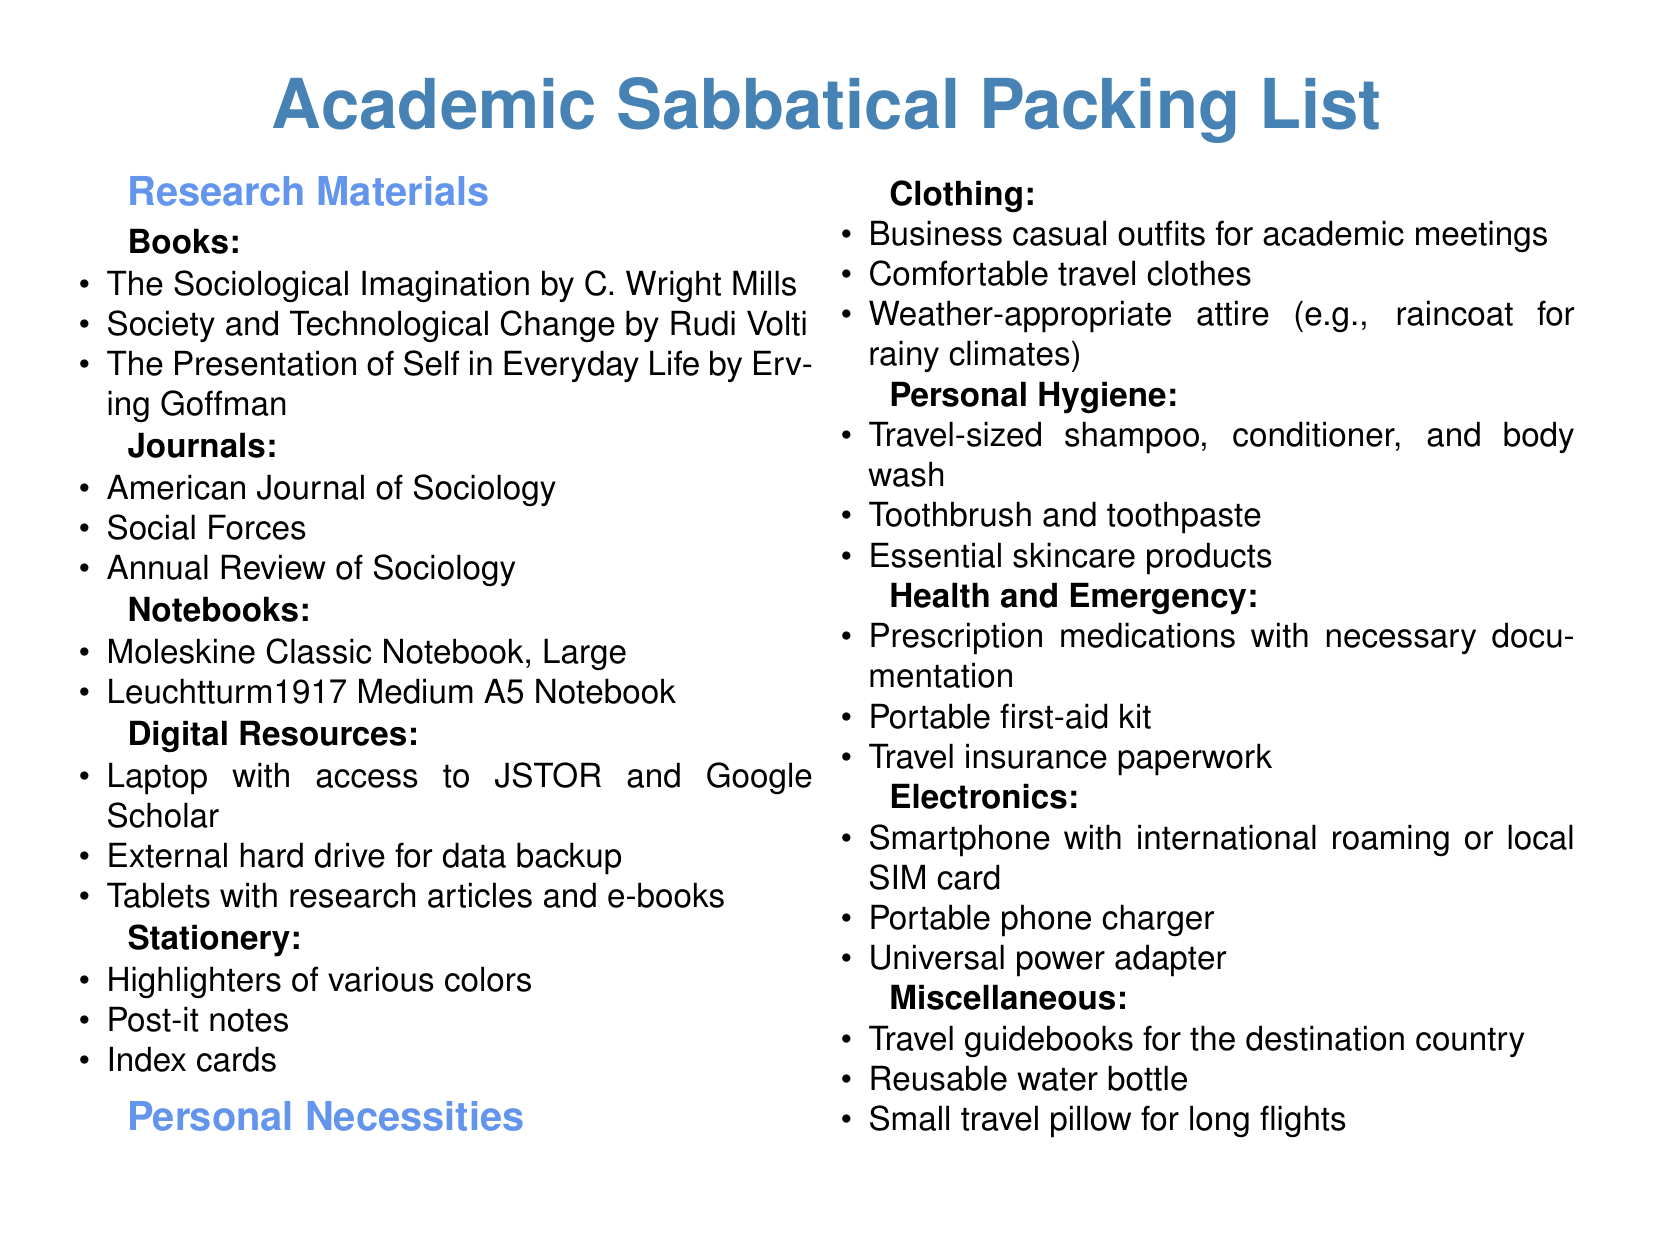What is the title of a book by Erving Goffman? The document lists "The Presentation of Self in Everyday Life" as a book by Erving Goffman in the research materials section.
Answer: The Presentation of Self in Everyday Life How many journals are listed? The document includes three journals under the journals section.
Answer: 3 What type of notebook is mentioned as a classic option? The document specifies the "Moleskine Classic Notebook, Large" under notebooks.
Answer: Moleskine Classic Notebook, Large What clothing category mentions outfits for meetings? The document states that "Business casual outfits for academic meetings" are included in the clothing section.
Answer: Business casual outfits What is included in the health and emergency section? The document lists "Prescription medications with necessary documentation" as an item under the health and emergency section.
Answer: Prescription medications with necessary documentation Which electronic item is suggested for charging? The document includes "Portable phone charger" in the electronics section.
Answer: Portable phone charger How many travel guidebooks are recommended? The document does not specify a number; it simply includes "Travel guidebooks for the destination country" in the miscellaneous section.
Answer: Travel guidebooks What type of attire is recommended for rainy climates? The document notes "raincoat for rainy climates" in the clothing category.
Answer: raincoat What is one of the personal hygiene items listed in the document? The document lists "Travel-sized shampoo, conditioner, and body wash" as personal hygiene items.
Answer: Travel-sized shampoo, conditioner, and body wash 